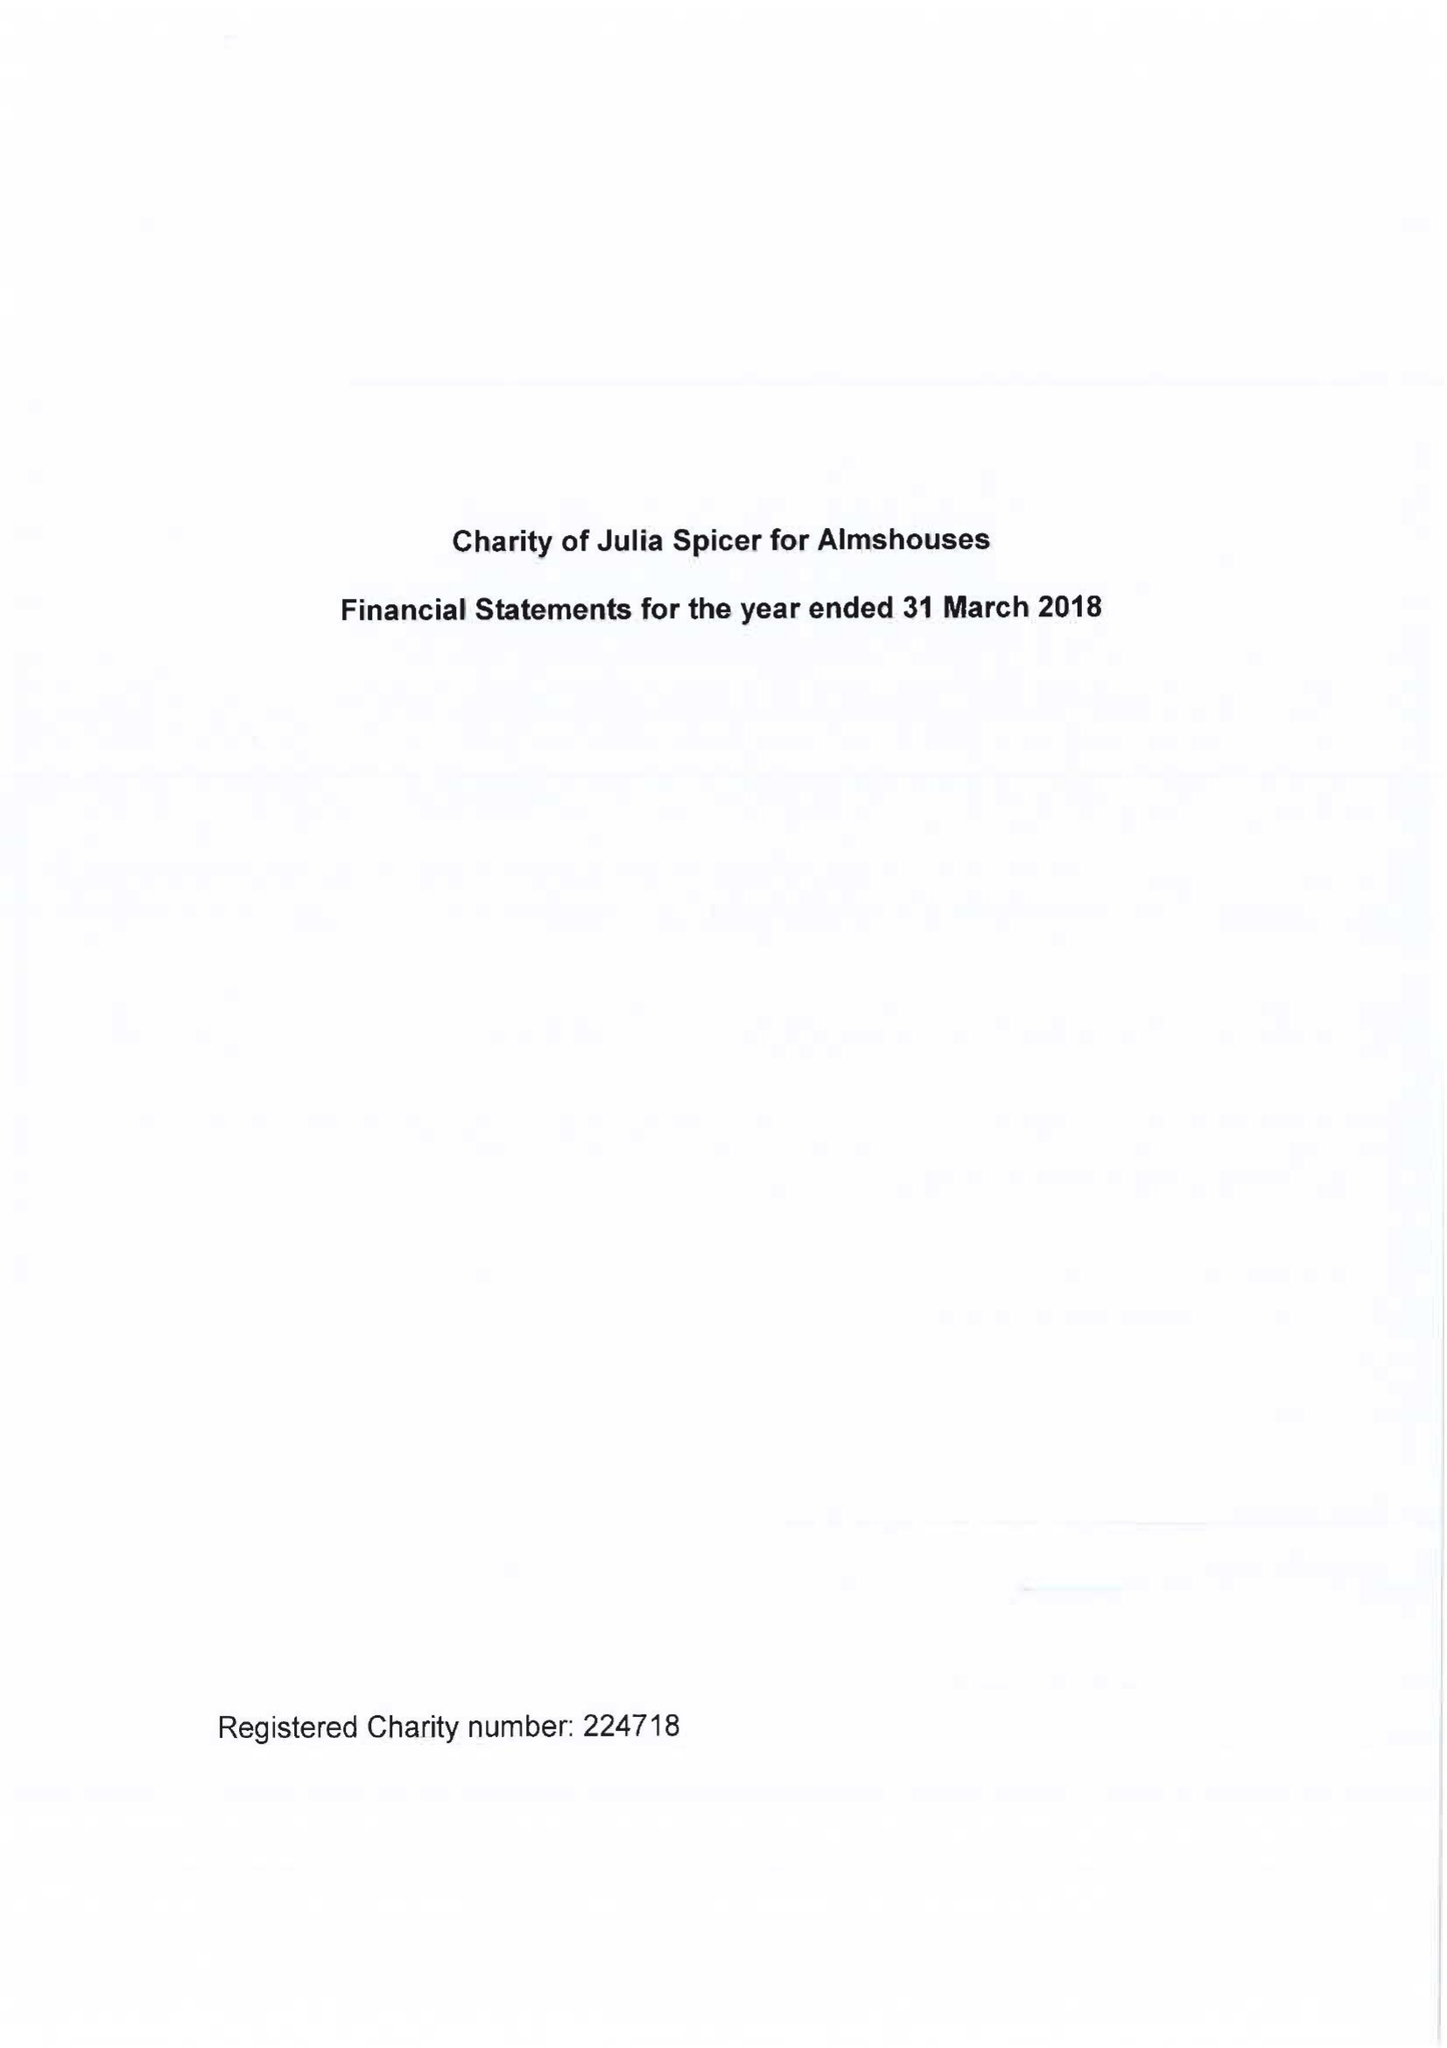What is the value for the charity_number?
Answer the question using a single word or phrase. 224718 